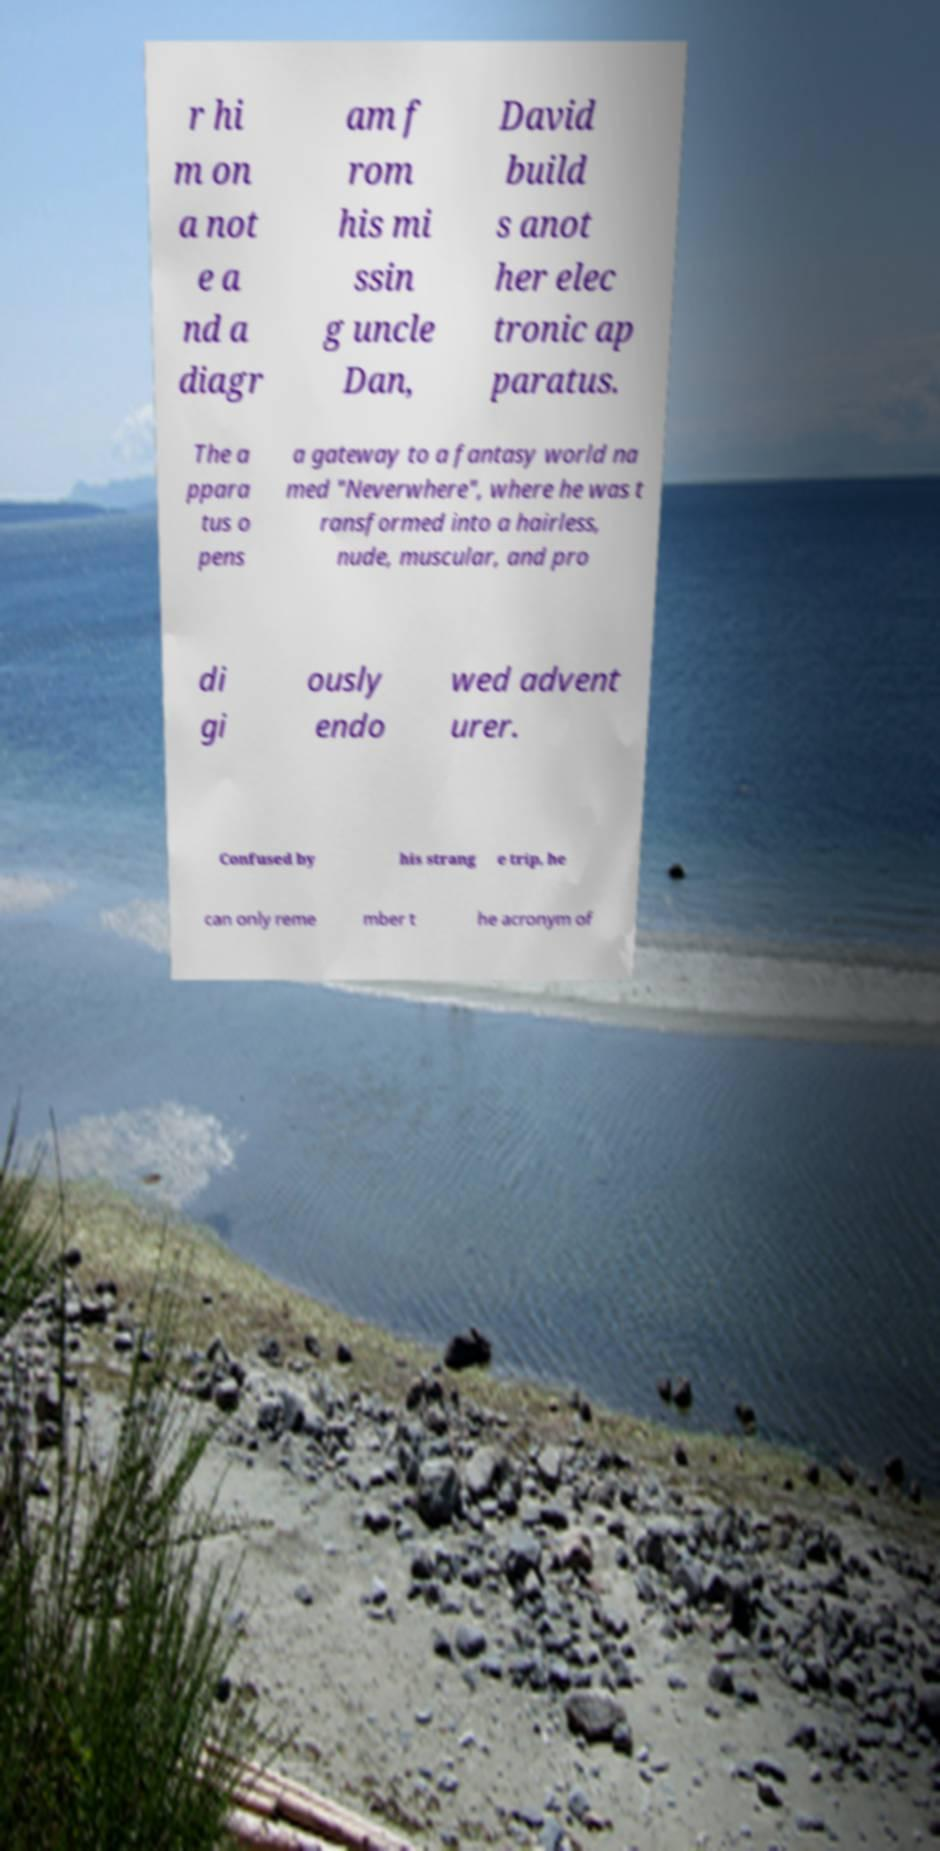There's text embedded in this image that I need extracted. Can you transcribe it verbatim? r hi m on a not e a nd a diagr am f rom his mi ssin g uncle Dan, David build s anot her elec tronic ap paratus. The a ppara tus o pens a gateway to a fantasy world na med "Neverwhere", where he was t ransformed into a hairless, nude, muscular, and pro di gi ously endo wed advent urer. Confused by his strang e trip, he can only reme mber t he acronym of 